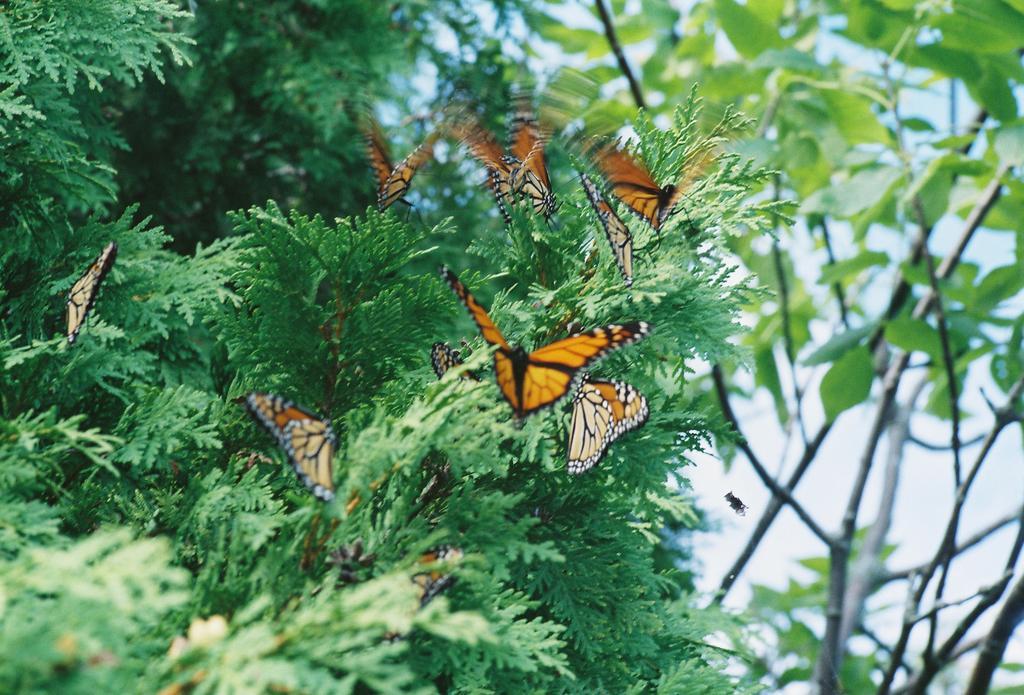How would you summarize this image in a sentence or two? In this image we can see many plants. There is an insect in the image. There are many butterflies sitting on the plant in the image. There is a sky in the image. 